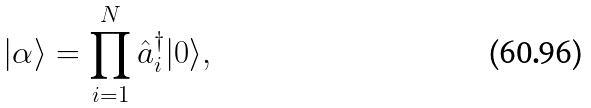Convert formula to latex. <formula><loc_0><loc_0><loc_500><loc_500>| \alpha \rangle = \prod _ { i = 1 } ^ { N } \hat { a } ^ { \dagger } _ { i } | 0 \rangle ,</formula> 